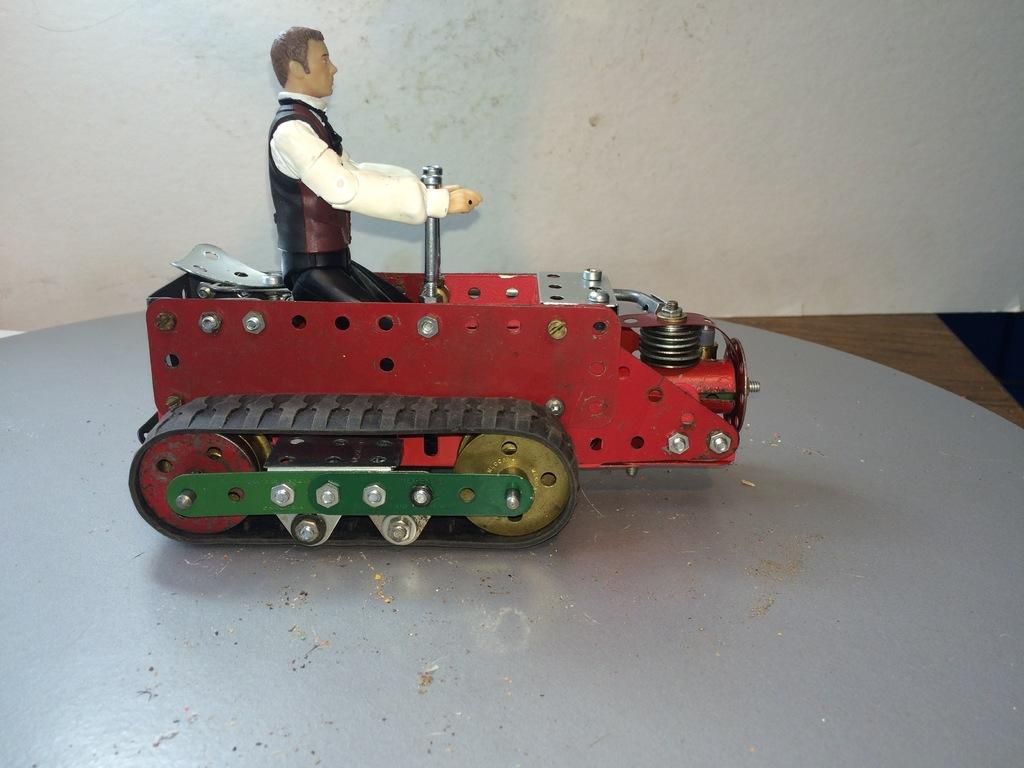What type of toy is in the image? The toy is in the shape of a crawler vehicle. Where is the toy located in the image? The toy is on a wooden table on the right side of the image. What can be seen in the background of the image? There is a wall visible in the background of the image. How many kittens are sitting on the crawler vehicle in the image? There are no kittens present in the image; it features a toy crawler vehicle on a wooden table. What is the altitude of the crawler vehicle in the image? The altitude of the crawler vehicle cannot be determined from the image, as it is a two-dimensional representation. 